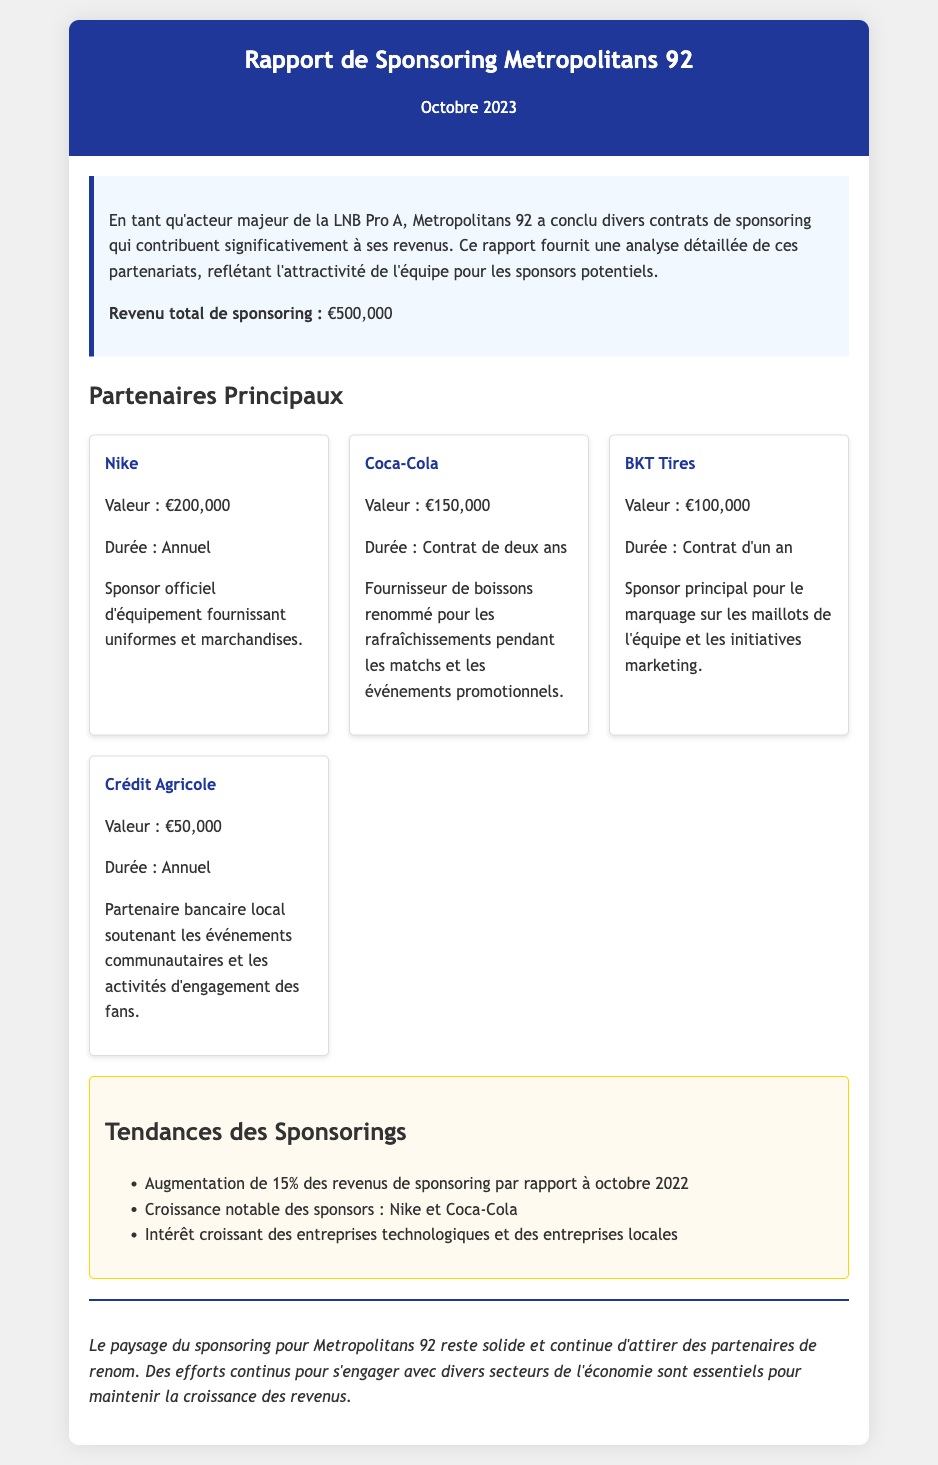Quelle est la valeur totale de sponsoring ? La valeur totale de sponsoring est indiquée sous la section « Résumé », qui mentionne « Revenu total de sponsoring ».
Answer: €500,000 Qui est le sponsor officiel d'équipement ? Il est mentionné sous les « Partenaires Principaux », où Nike est spécifié comme le sponsor officiel fournissant uniformes et marchandises.
Answer: Nike Quelle est la durée du contrat avec Coca-Cola ? La durée est précisée dans la section « Partenaires Principaux » pour Coca-Cola, qui mentionne un « Contrat de deux ans ».
Answer: Contrat de deux ans Quel pourcentage d'augmentation des revenus de sponsoring est mentionné ? Cela se trouve dans la section « Tendances des Sponsorings », où il mentionne une « Augmentation de 15% des revenus de sponsoring par rapport à octobre 2022 ».
Answer: 15% Quel est le montant du sponsoring de BKT Tires ? Le montant est spécifié dans la section « Partenaires Principaux » sous BKT Tires, qui indique la valeur du contrat.
Answer: €100,000 Quel sponsor a la valeur la plus élevée ? Cela peut être déterminé en regardant les valeurs des sponsors dans la section « Partenaires Principaux », où Nike montre la valeur la plus élevée.
Answer: Nike Quel type d'entité est Crédit Agricole ? Cette information est fournie dans la section « Partenaires Principaux », où elle décrit Crédit Agricole comme un « Partenaire bancaire local ».
Answer: Partenaire bancaire local Quels secteurs montrent un intérêt croissant pour le sponsoring ? Dans la section « Tendances des Sponsorings », il est mentionné que les entreprises technologiques et les entreprises locales montrent un intérêt croissant.
Answer: Entreprises technologiques et entreprises locales 